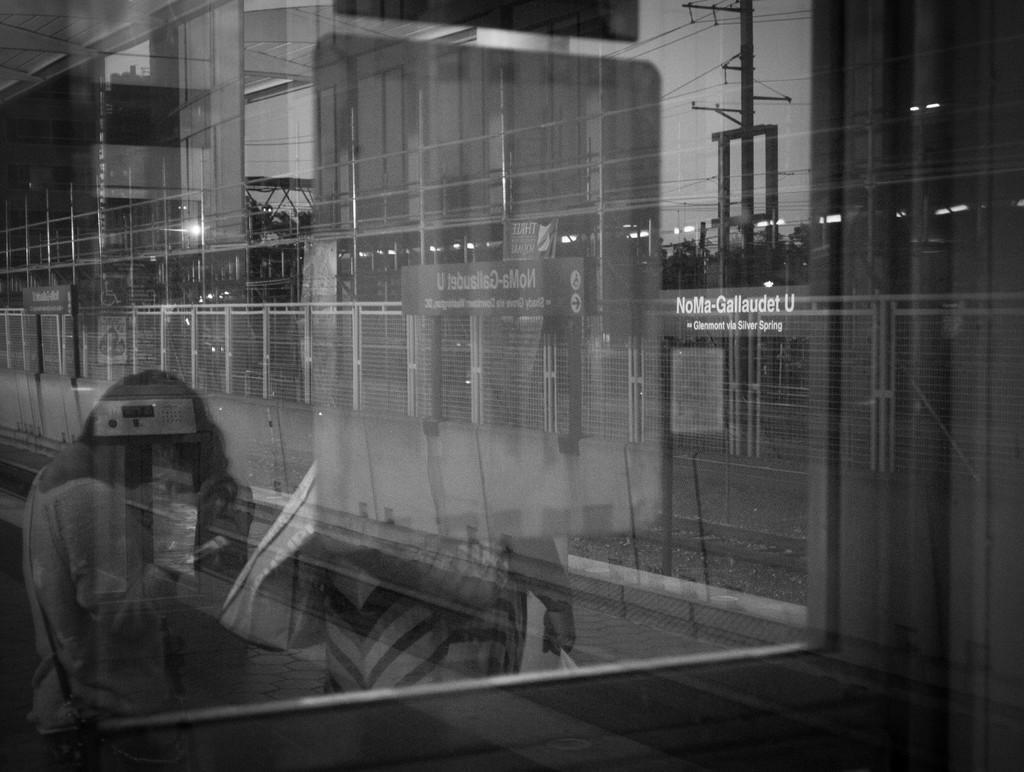Could you give a brief overview of what you see in this image? This is the black and white image and we can see the reflection of two persons standing on the glass and the place looks like a railway platform and we can see power poles, railway track and some other things. We can also see the reflection of a board with some text on the glass. 